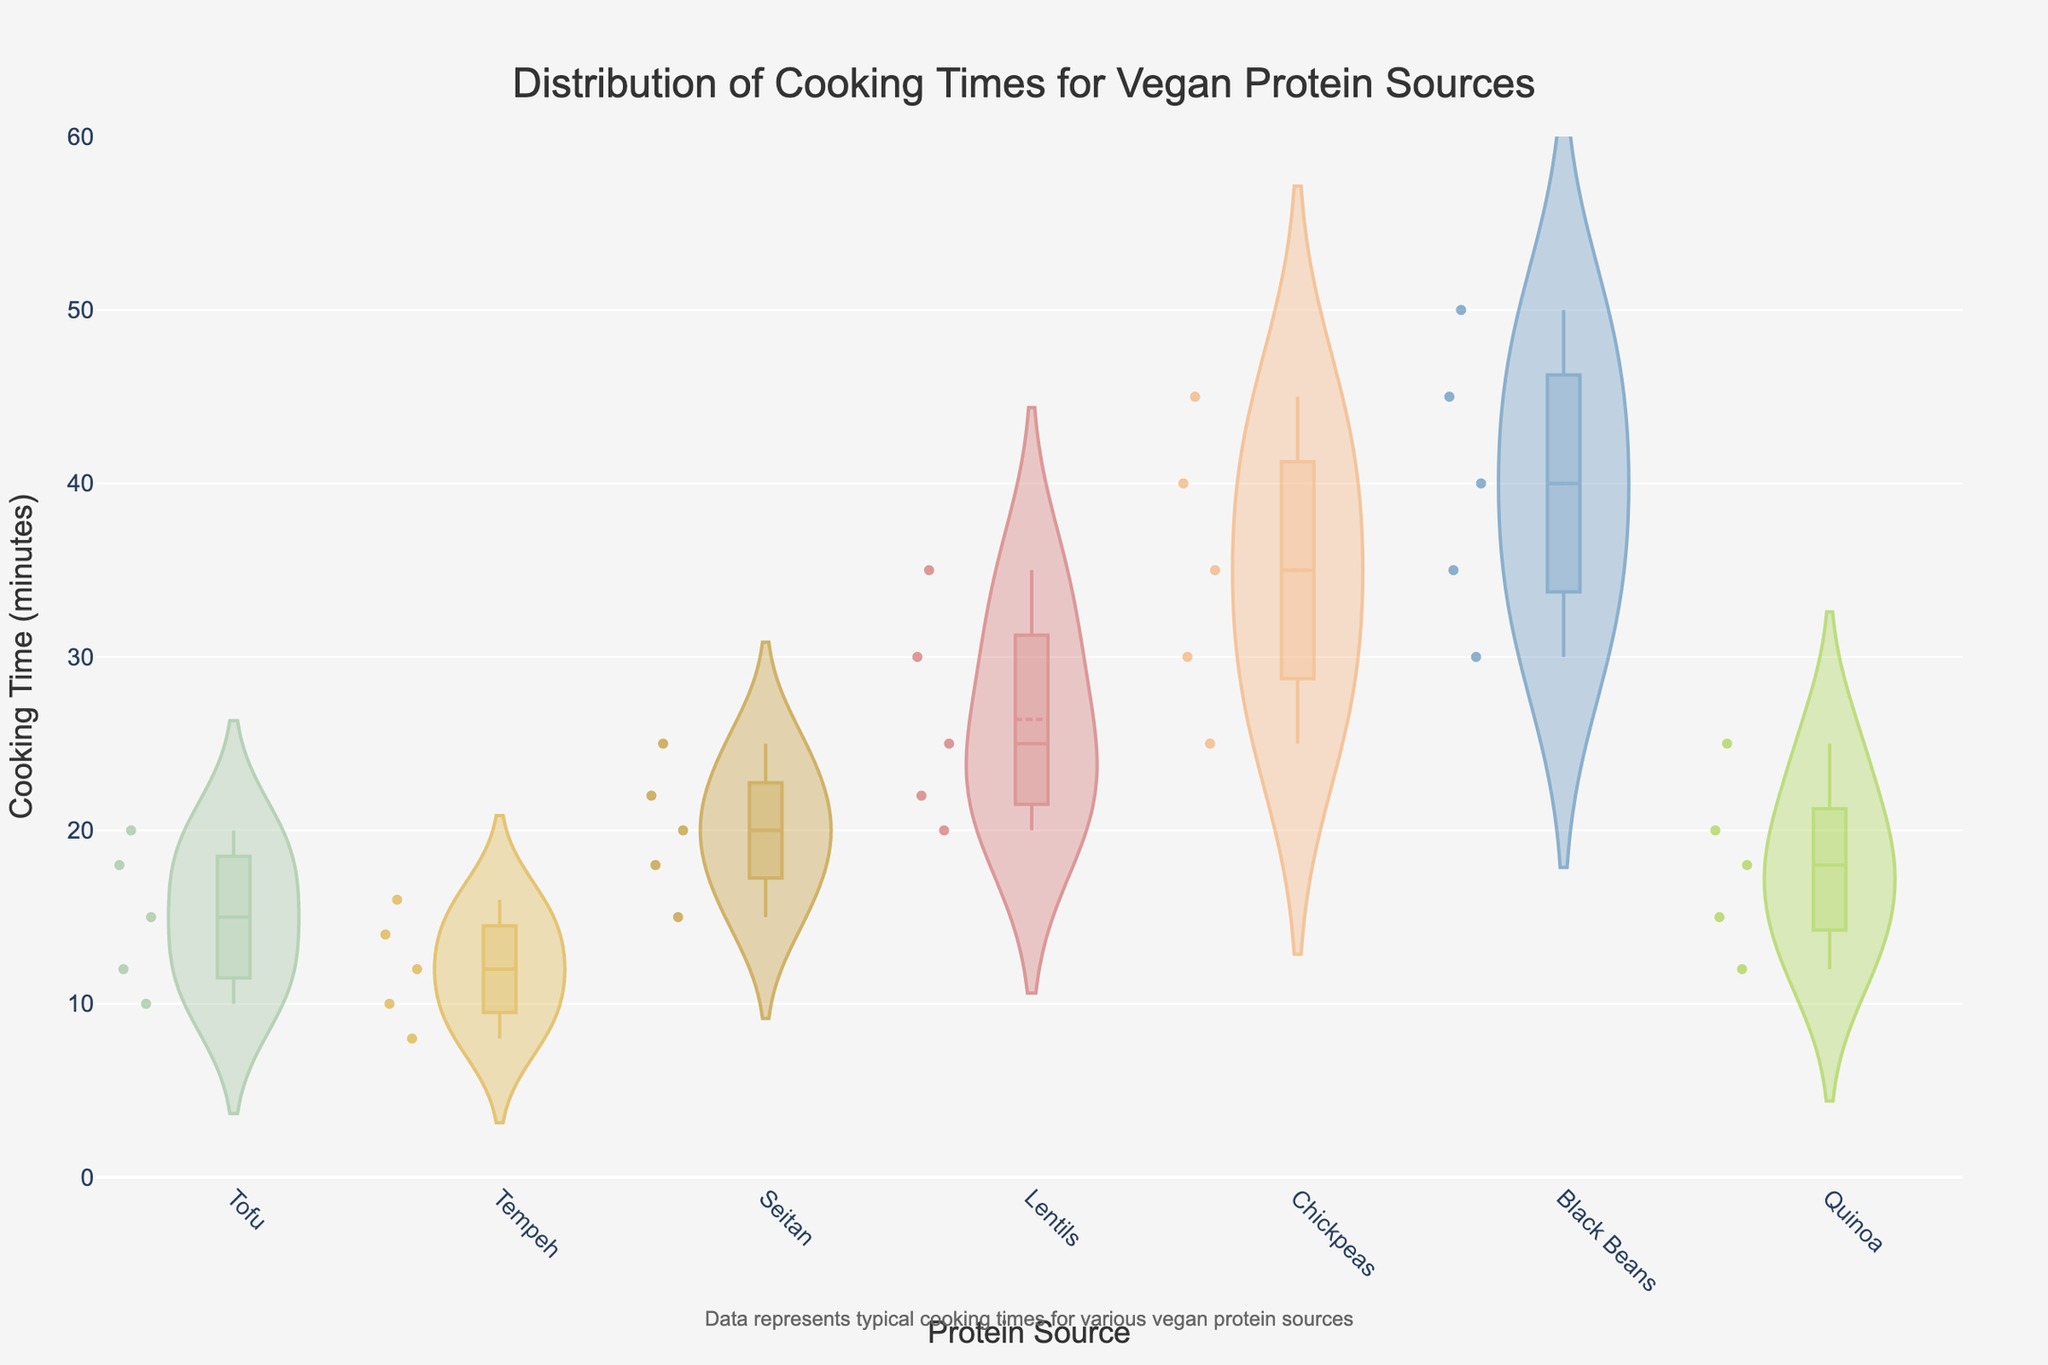What's the title of the figure? The title is the text appearing at the top of the plot. Read the text positioned centrally at the top.
Answer: Distribution of Cooking Times for Vegan Protein Sources What is the y-axis representing in the plot? Look at the label next to the y-axis to understand what it shows.
Answer: Cooking Time (minutes) What colors represent Tofu and Tempeh? Identify the boxes or traces of the violin plot for Tofu and Tempeh and note the colors they are shaded in.
Answer: Tofu: light green, Tempeh: golden Which vegan protein source has the widest range of cooking times? Determine the protein source with the longest spread in the violin plot from top to bottom.
Answer: Black Beans Which protein source has the narrowest range of cooking times? Find the most compact violin plot, indicating the smallest spread from top to bottom.
Answer: Tempeh What's the average cooking time for Lentils? Identify the mean line within the Lentils violin plot and read the associated cooking time.
Answer: 26 minutes Compare the median cooking times of Tofu and Chickpeas. Which one is higher? Locate the median lines for Tofu and Chickpeas and then compare their positions on the y-axis.
Answer: Chickpeas What is the cooking time range for Quinoa? Identify the lowest and highest points of the Quinoa violin plot.
Answer: 12 to 25 minutes Which vegan protein source has the highest median cooking time? Find the violin plot with the median line situated highest on the y-axis.
Answer: Black Beans How does the cooking time distribution of Seitan compare to Quinoa? Note the shape and spread of Seitan and Quinoa's violin plots, comparing where most data points lie and their ranges.
Answer: Seitan has a higher cooking time and a wider range compared to Quinoa 